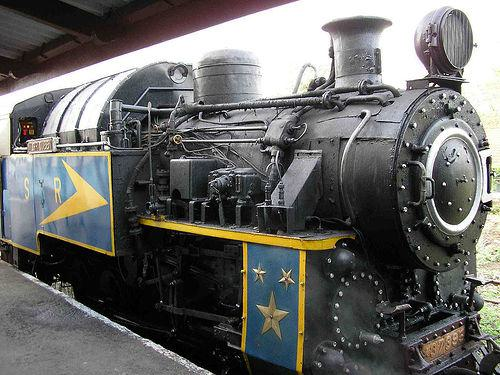Can you tell me the era or time period this train might belong to based on its design? The train's design, with its steam engine and classic features, suggests it might be from the late 19th to early 20th century, a time when steam locomotives were prevalent. 